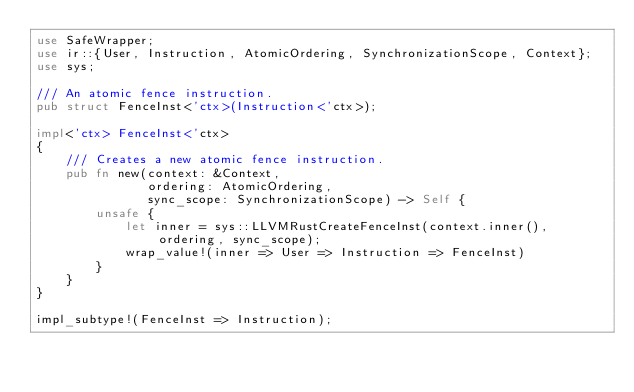Convert code to text. <code><loc_0><loc_0><loc_500><loc_500><_Rust_>use SafeWrapper;
use ir::{User, Instruction, AtomicOrdering, SynchronizationScope, Context};
use sys;

/// An atomic fence instruction.
pub struct FenceInst<'ctx>(Instruction<'ctx>);

impl<'ctx> FenceInst<'ctx>
{
    /// Creates a new atomic fence instruction.
    pub fn new(context: &Context,
               ordering: AtomicOrdering,
               sync_scope: SynchronizationScope) -> Self {
        unsafe {
            let inner = sys::LLVMRustCreateFenceInst(context.inner(), ordering, sync_scope);
            wrap_value!(inner => User => Instruction => FenceInst)
        }
    }
}

impl_subtype!(FenceInst => Instruction);
</code> 